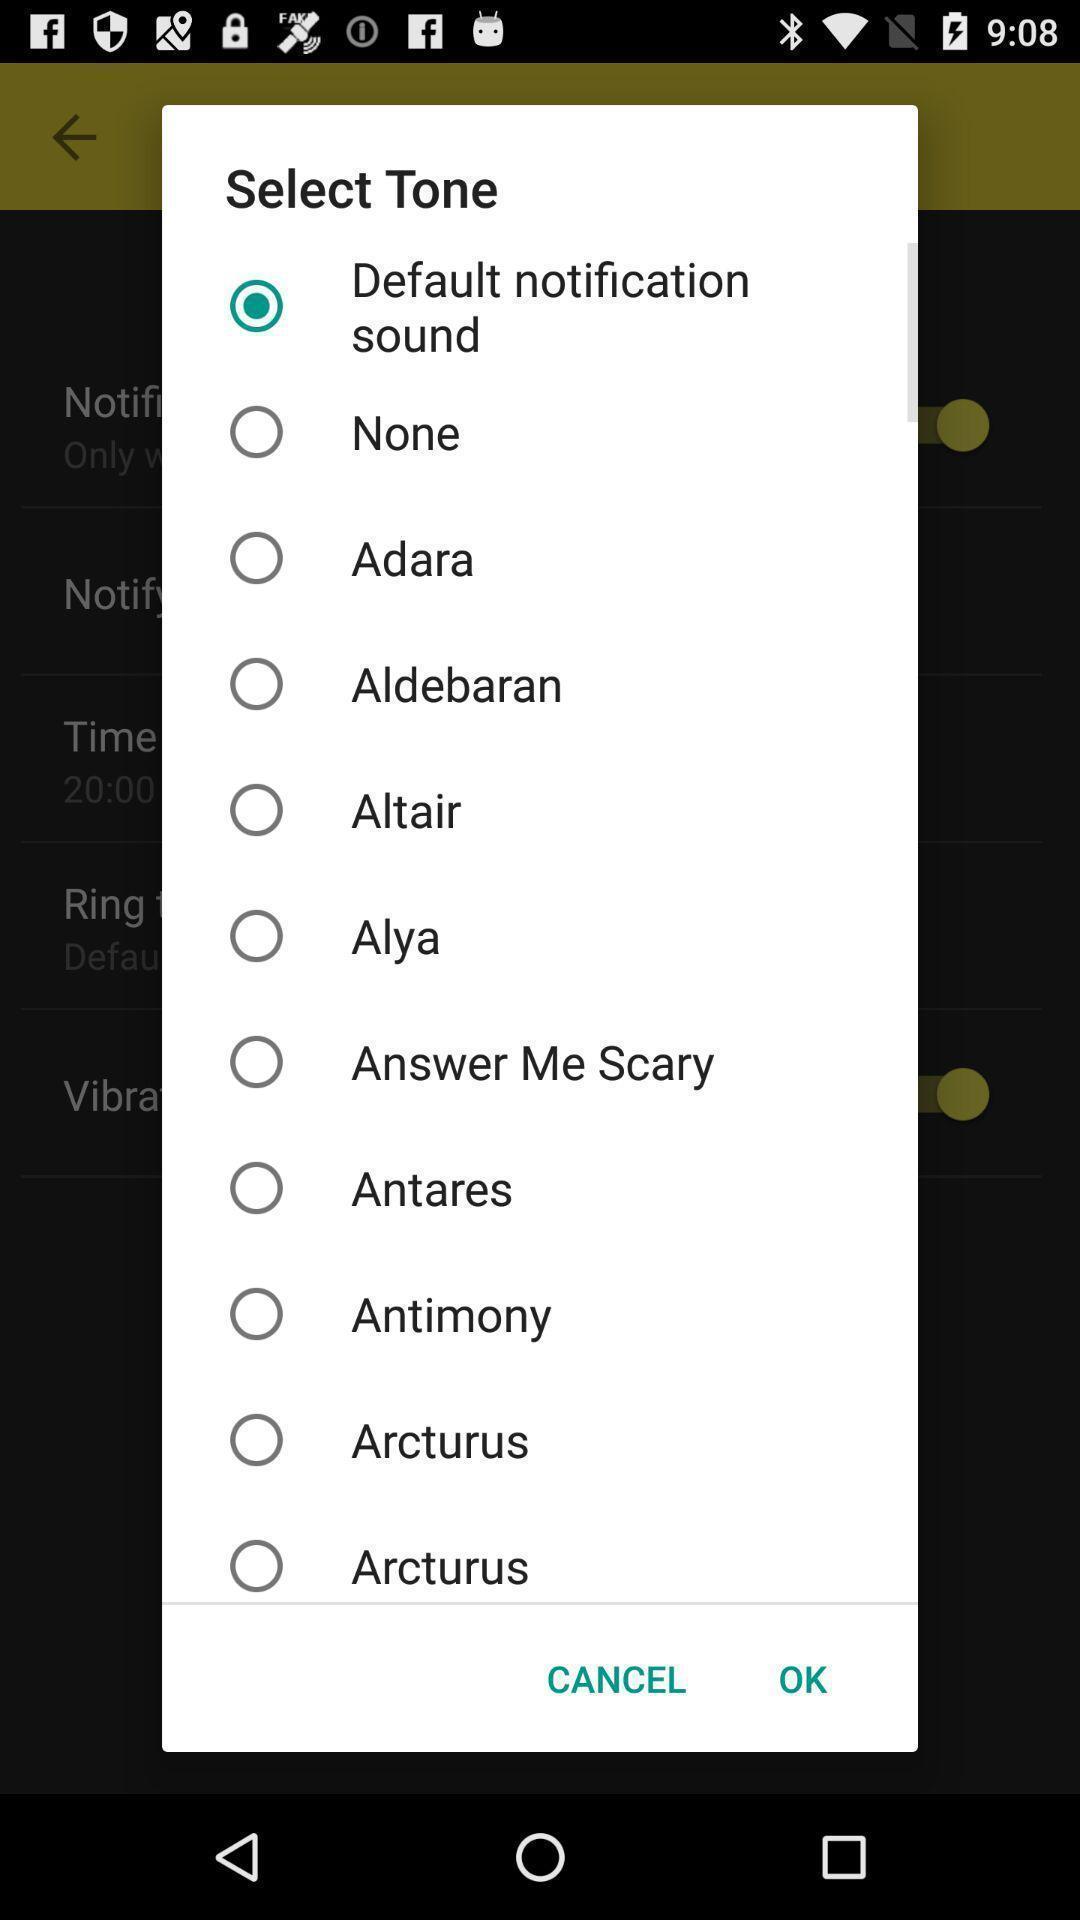Explain what's happening in this screen capture. Various preferences to be selected of a ringtones app. 